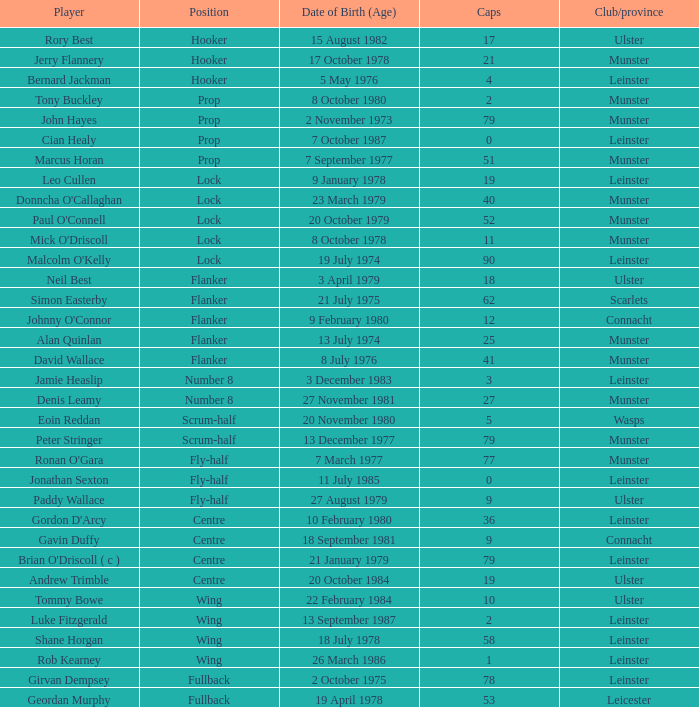What is the number of caps earned by mick o'driscoll, the lock for munster club/province? 1.0. 